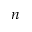Convert formula to latex. <formula><loc_0><loc_0><loc_500><loc_500>n</formula> 